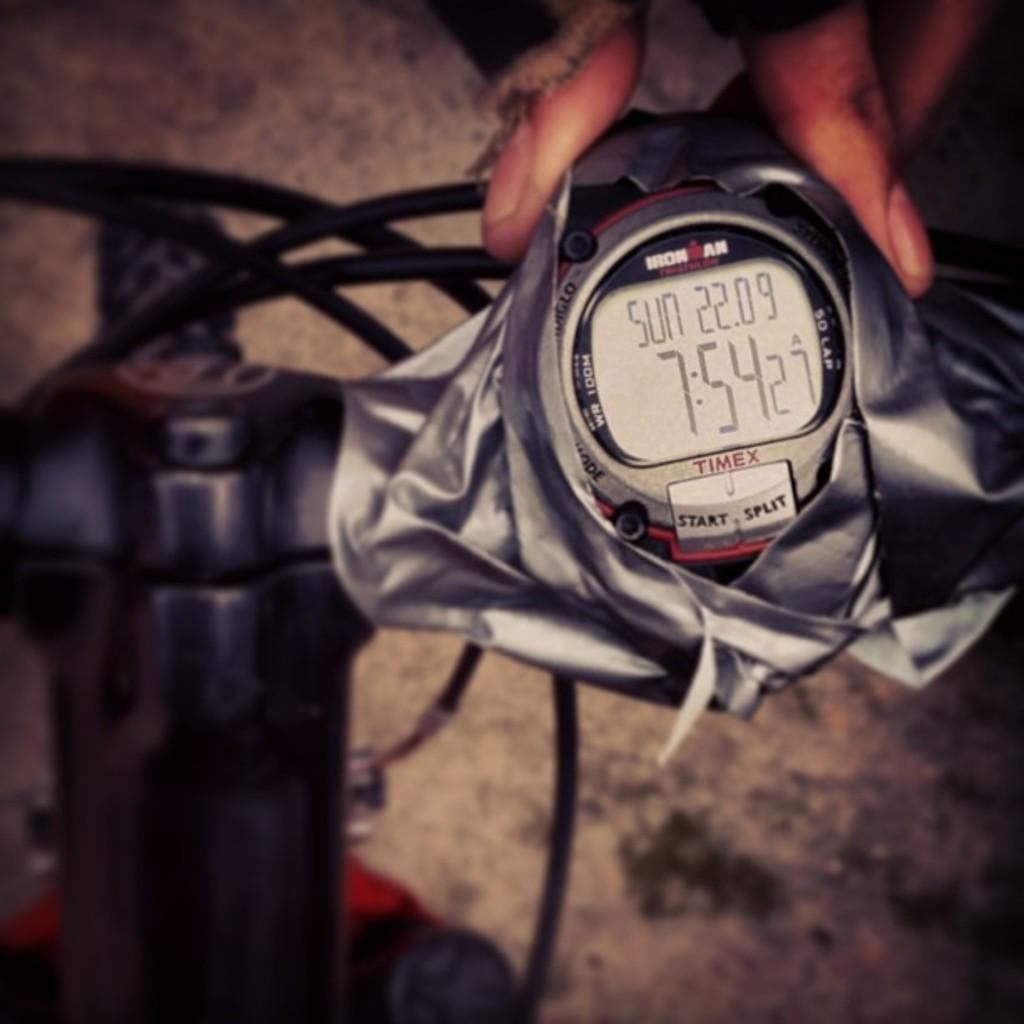<image>
Provide a brief description of the given image. The Timex timepiece recorded the date as Sunday the 22nd of '09 and the time as 7:54:27am. 